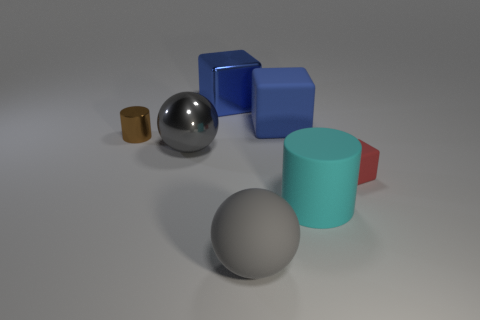Are there any brown cylinders right of the large rubber object behind the tiny shiny cylinder?
Your answer should be compact. No. There is a gray object that is in front of the tiny red block; what material is it?
Offer a terse response. Rubber. Is the big gray ball behind the cyan rubber object made of the same material as the big gray ball right of the gray shiny sphere?
Your response must be concise. No. Is the number of gray matte things that are on the right side of the red cube the same as the number of small brown cylinders right of the big cylinder?
Your response must be concise. Yes. How many other large objects are made of the same material as the large cyan object?
Your answer should be compact. 2. There is a metal object that is the same color as the large rubber block; what shape is it?
Your response must be concise. Cube. There is a gray object that is left of the big gray object that is in front of the large metal ball; what size is it?
Give a very brief answer. Large. There is a gray object that is in front of the tiny red cube; is its shape the same as the gray object that is behind the cyan rubber thing?
Make the answer very short. Yes. Are there an equal number of big cyan objects that are behind the tiny red matte block and tiny rubber objects?
Provide a short and direct response. No. What color is the other metal thing that is the same shape as the red object?
Keep it short and to the point. Blue. 